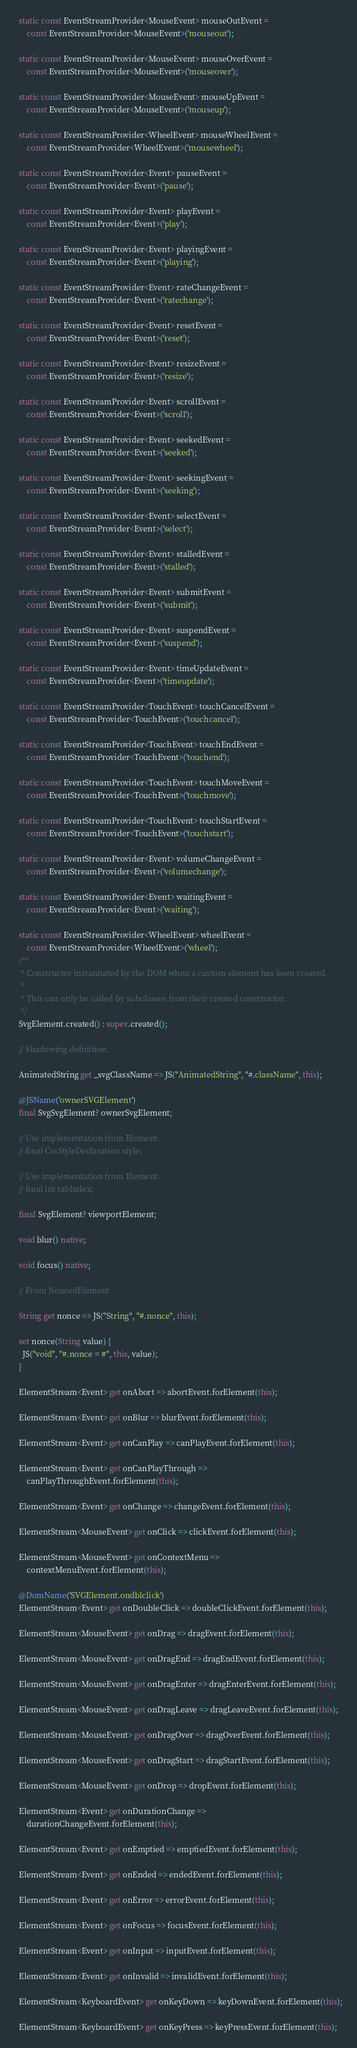Convert code to text. <code><loc_0><loc_0><loc_500><loc_500><_Dart_>  static const EventStreamProvider<MouseEvent> mouseOutEvent =
      const EventStreamProvider<MouseEvent>('mouseout');

  static const EventStreamProvider<MouseEvent> mouseOverEvent =
      const EventStreamProvider<MouseEvent>('mouseover');

  static const EventStreamProvider<MouseEvent> mouseUpEvent =
      const EventStreamProvider<MouseEvent>('mouseup');

  static const EventStreamProvider<WheelEvent> mouseWheelEvent =
      const EventStreamProvider<WheelEvent>('mousewheel');

  static const EventStreamProvider<Event> pauseEvent =
      const EventStreamProvider<Event>('pause');

  static const EventStreamProvider<Event> playEvent =
      const EventStreamProvider<Event>('play');

  static const EventStreamProvider<Event> playingEvent =
      const EventStreamProvider<Event>('playing');

  static const EventStreamProvider<Event> rateChangeEvent =
      const EventStreamProvider<Event>('ratechange');

  static const EventStreamProvider<Event> resetEvent =
      const EventStreamProvider<Event>('reset');

  static const EventStreamProvider<Event> resizeEvent =
      const EventStreamProvider<Event>('resize');

  static const EventStreamProvider<Event> scrollEvent =
      const EventStreamProvider<Event>('scroll');

  static const EventStreamProvider<Event> seekedEvent =
      const EventStreamProvider<Event>('seeked');

  static const EventStreamProvider<Event> seekingEvent =
      const EventStreamProvider<Event>('seeking');

  static const EventStreamProvider<Event> selectEvent =
      const EventStreamProvider<Event>('select');

  static const EventStreamProvider<Event> stalledEvent =
      const EventStreamProvider<Event>('stalled');

  static const EventStreamProvider<Event> submitEvent =
      const EventStreamProvider<Event>('submit');

  static const EventStreamProvider<Event> suspendEvent =
      const EventStreamProvider<Event>('suspend');

  static const EventStreamProvider<Event> timeUpdateEvent =
      const EventStreamProvider<Event>('timeupdate');

  static const EventStreamProvider<TouchEvent> touchCancelEvent =
      const EventStreamProvider<TouchEvent>('touchcancel');

  static const EventStreamProvider<TouchEvent> touchEndEvent =
      const EventStreamProvider<TouchEvent>('touchend');

  static const EventStreamProvider<TouchEvent> touchMoveEvent =
      const EventStreamProvider<TouchEvent>('touchmove');

  static const EventStreamProvider<TouchEvent> touchStartEvent =
      const EventStreamProvider<TouchEvent>('touchstart');

  static const EventStreamProvider<Event> volumeChangeEvent =
      const EventStreamProvider<Event>('volumechange');

  static const EventStreamProvider<Event> waitingEvent =
      const EventStreamProvider<Event>('waiting');

  static const EventStreamProvider<WheelEvent> wheelEvent =
      const EventStreamProvider<WheelEvent>('wheel');
  /**
   * Constructor instantiated by the DOM when a custom element has been created.
   *
   * This can only be called by subclasses from their created constructor.
   */
  SvgElement.created() : super.created();

  // Shadowing definition.

  AnimatedString get _svgClassName => JS("AnimatedString", "#.className", this);

  @JSName('ownerSVGElement')
  final SvgSvgElement? ownerSvgElement;

  // Use implementation from Element.
  // final CssStyleDeclaration style;

  // Use implementation from Element.
  // final int tabIndex;

  final SvgElement? viewportElement;

  void blur() native;

  void focus() native;

  // From NoncedElement

  String get nonce => JS("String", "#.nonce", this);

  set nonce(String value) {
    JS("void", "#.nonce = #", this, value);
  }

  ElementStream<Event> get onAbort => abortEvent.forElement(this);

  ElementStream<Event> get onBlur => blurEvent.forElement(this);

  ElementStream<Event> get onCanPlay => canPlayEvent.forElement(this);

  ElementStream<Event> get onCanPlayThrough =>
      canPlayThroughEvent.forElement(this);

  ElementStream<Event> get onChange => changeEvent.forElement(this);

  ElementStream<MouseEvent> get onClick => clickEvent.forElement(this);

  ElementStream<MouseEvent> get onContextMenu =>
      contextMenuEvent.forElement(this);

  @DomName('SVGElement.ondblclick')
  ElementStream<Event> get onDoubleClick => doubleClickEvent.forElement(this);

  ElementStream<MouseEvent> get onDrag => dragEvent.forElement(this);

  ElementStream<MouseEvent> get onDragEnd => dragEndEvent.forElement(this);

  ElementStream<MouseEvent> get onDragEnter => dragEnterEvent.forElement(this);

  ElementStream<MouseEvent> get onDragLeave => dragLeaveEvent.forElement(this);

  ElementStream<MouseEvent> get onDragOver => dragOverEvent.forElement(this);

  ElementStream<MouseEvent> get onDragStart => dragStartEvent.forElement(this);

  ElementStream<MouseEvent> get onDrop => dropEvent.forElement(this);

  ElementStream<Event> get onDurationChange =>
      durationChangeEvent.forElement(this);

  ElementStream<Event> get onEmptied => emptiedEvent.forElement(this);

  ElementStream<Event> get onEnded => endedEvent.forElement(this);

  ElementStream<Event> get onError => errorEvent.forElement(this);

  ElementStream<Event> get onFocus => focusEvent.forElement(this);

  ElementStream<Event> get onInput => inputEvent.forElement(this);

  ElementStream<Event> get onInvalid => invalidEvent.forElement(this);

  ElementStream<KeyboardEvent> get onKeyDown => keyDownEvent.forElement(this);

  ElementStream<KeyboardEvent> get onKeyPress => keyPressEvent.forElement(this);
</code> 